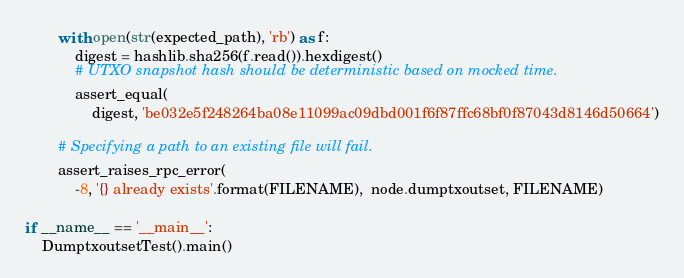<code> <loc_0><loc_0><loc_500><loc_500><_Python_>
        with open(str(expected_path), 'rb') as f:
            digest = hashlib.sha256(f.read()).hexdigest()
            # UTXO snapshot hash should be deterministic based on mocked time.
            assert_equal(
                digest, 'be032e5f248264ba08e11099ac09dbd001f6f87ffc68bf0f87043d8146d50664')

        # Specifying a path to an existing file will fail.
        assert_raises_rpc_error(
            -8, '{} already exists'.format(FILENAME),  node.dumptxoutset, FILENAME)

if __name__ == '__main__':
    DumptxoutsetTest().main()
</code> 